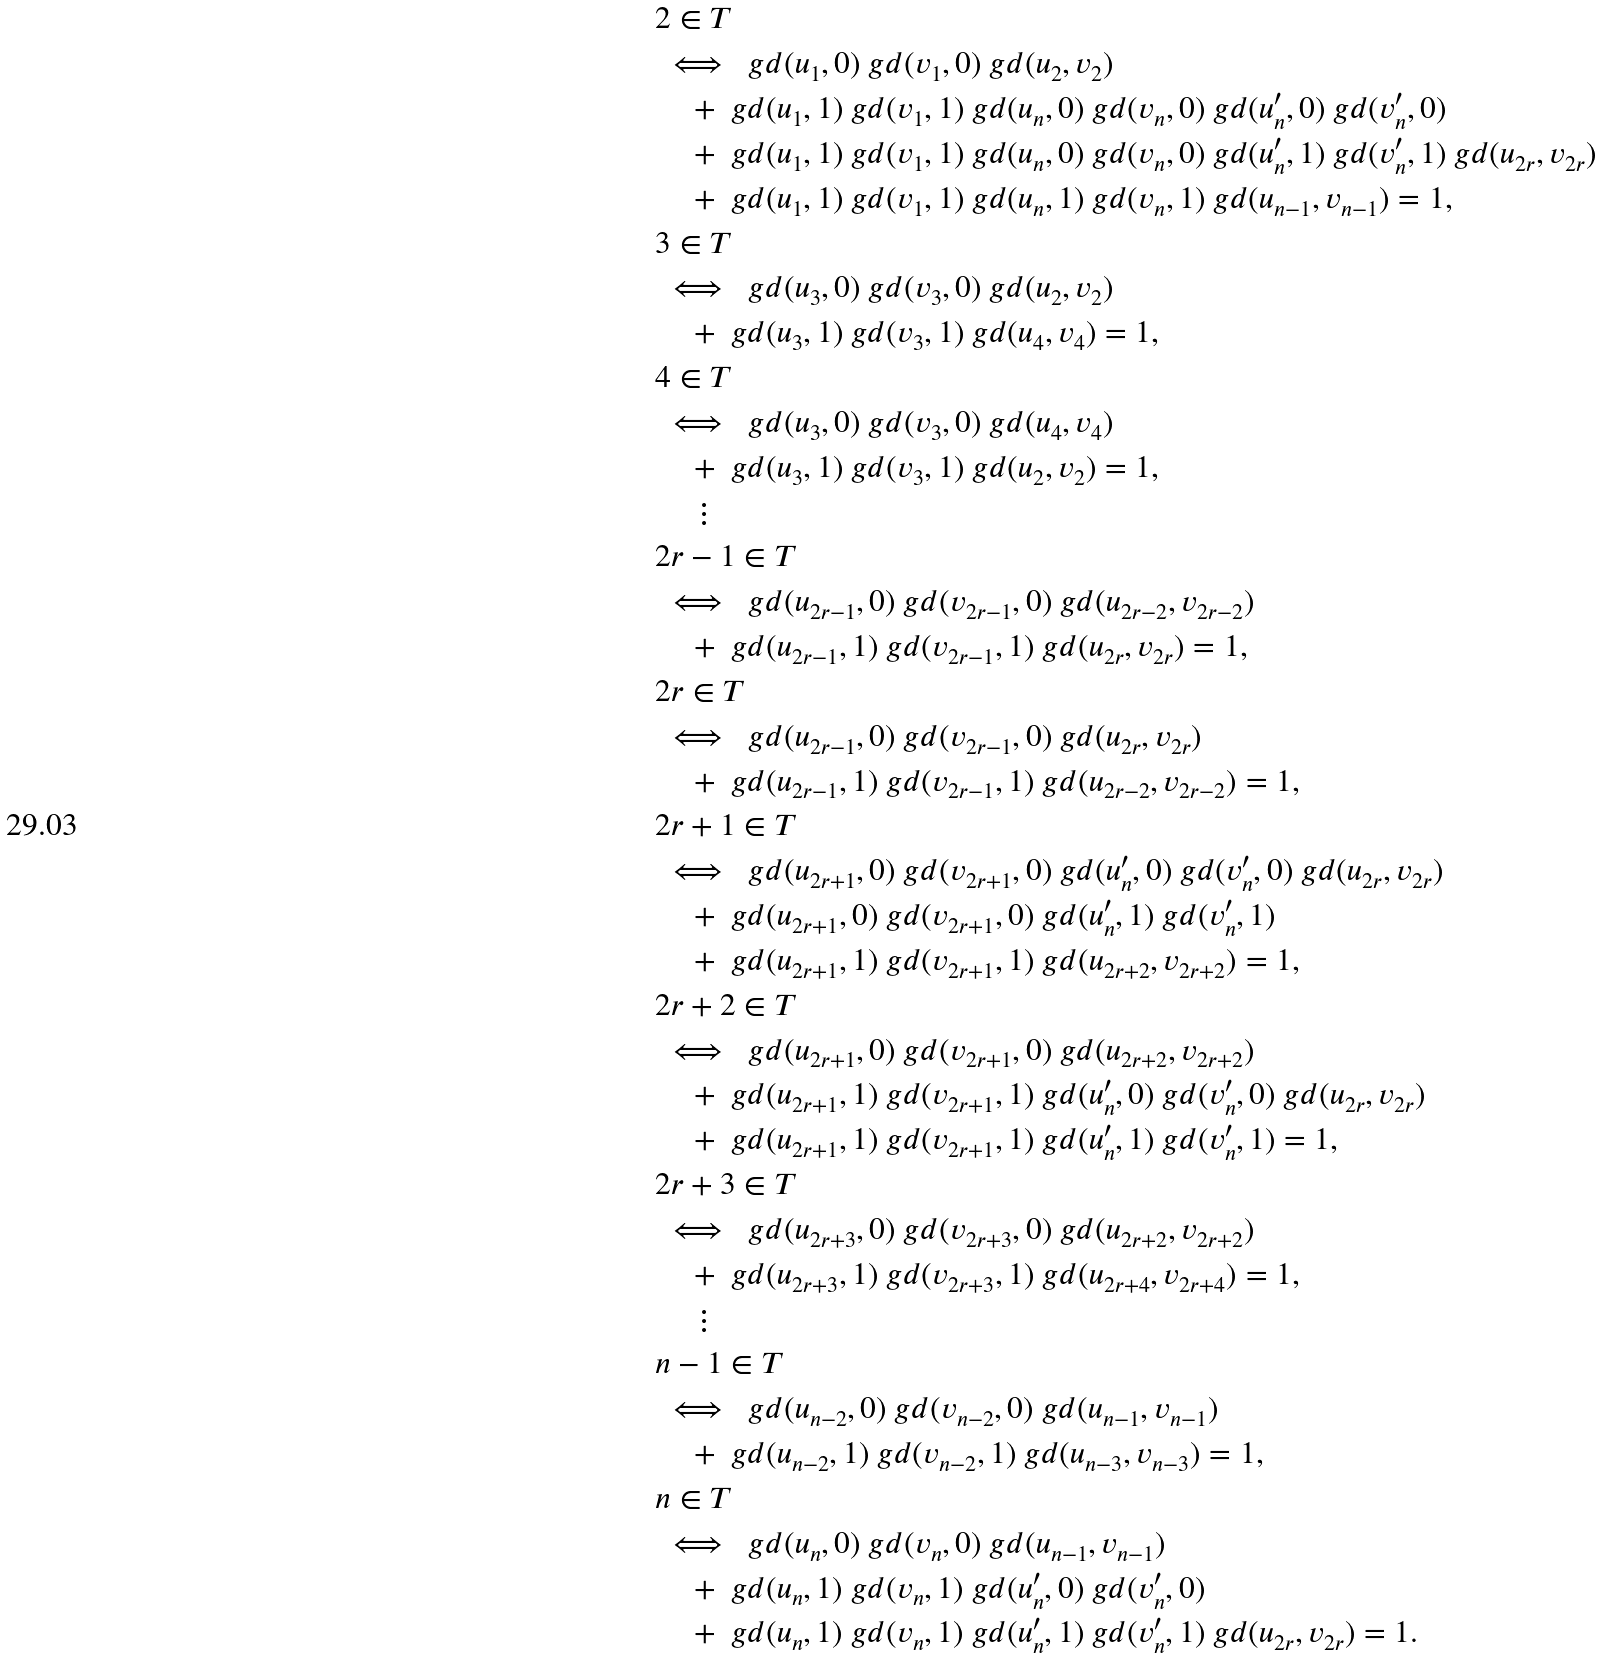Convert formula to latex. <formula><loc_0><loc_0><loc_500><loc_500>& 2 \in T \\ & \iff \ g d ( u _ { 1 } , 0 ) \ g d ( v _ { 1 } , 0 ) \ g d ( u _ { 2 } , v _ { 2 } ) \\ & \quad + \ g d ( u _ { 1 } , 1 ) \ g d ( v _ { 1 } , 1 ) \ g d ( u _ { n } , 0 ) \ g d ( v _ { n } , 0 ) \ g d ( u _ { n } ^ { \prime } , 0 ) \ g d ( v _ { n } ^ { \prime } , 0 ) \\ & \quad + \ g d ( u _ { 1 } , 1 ) \ g d ( v _ { 1 } , 1 ) \ g d ( u _ { n } , 0 ) \ g d ( v _ { n } , 0 ) \ g d ( u _ { n } ^ { \prime } , 1 ) \ g d ( v _ { n } ^ { \prime } , 1 ) \ g d ( u _ { 2 r } , v _ { 2 r } ) \\ & \quad + \ g d ( u _ { 1 } , 1 ) \ g d ( v _ { 1 } , 1 ) \ g d ( u _ { n } , 1 ) \ g d ( v _ { n } , 1 ) \ g d ( u _ { n - 1 } , v _ { n - 1 } ) = 1 , \\ & 3 \in T \\ & \iff \ g d ( u _ { 3 } , 0 ) \ g d ( v _ { 3 } , 0 ) \ g d ( u _ { 2 } , v _ { 2 } ) \\ & \quad + \ g d ( u _ { 3 } , 1 ) \ g d ( v _ { 3 } , 1 ) \ g d ( u _ { 4 } , v _ { 4 } ) = 1 , \\ & 4 \in T \\ & \iff \ g d ( u _ { 3 } , 0 ) \ g d ( v _ { 3 } , 0 ) \ g d ( u _ { 4 } , v _ { 4 } ) \\ & \quad + \ g d ( u _ { 3 } , 1 ) \ g d ( v _ { 3 } , 1 ) \ g d ( u _ { 2 } , v _ { 2 } ) = 1 , \\ & \quad \vdots \\ & 2 r - 1 \in T \\ & \iff \ g d ( u _ { 2 r - 1 } , 0 ) \ g d ( v _ { 2 r - 1 } , 0 ) \ g d ( u _ { 2 r - 2 } , v _ { 2 r - 2 } ) \\ & \quad + \ g d ( u _ { 2 r - 1 } , 1 ) \ g d ( v _ { 2 r - 1 } , 1 ) \ g d ( u _ { 2 r } , v _ { 2 r } ) = 1 , \\ & 2 r \in T \\ & \iff \ g d ( u _ { 2 r - 1 } , 0 ) \ g d ( v _ { 2 r - 1 } , 0 ) \ g d ( u _ { 2 r } , v _ { 2 r } ) \\ & \quad + \ g d ( u _ { 2 r - 1 } , 1 ) \ g d ( v _ { 2 r - 1 } , 1 ) \ g d ( u _ { 2 r - 2 } , v _ { 2 r - 2 } ) = 1 , \\ & 2 r + 1 \in T \\ & \iff \ g d ( u _ { 2 r + 1 } , 0 ) \ g d ( v _ { 2 r + 1 } , 0 ) \ g d ( u _ { n } ^ { \prime } , 0 ) \ g d ( v _ { n } ^ { \prime } , 0 ) \ g d ( u _ { 2 r } , v _ { 2 r } ) \\ & \quad + \ g d ( u _ { 2 r + 1 } , 0 ) \ g d ( v _ { 2 r + 1 } , 0 ) \ g d ( u _ { n } ^ { \prime } , 1 ) \ g d ( v _ { n } ^ { \prime } , 1 ) \\ & \quad + \ g d ( u _ { 2 r + 1 } , 1 ) \ g d ( v _ { 2 r + 1 } , 1 ) \ g d ( u _ { 2 r + 2 } , v _ { 2 r + 2 } ) = 1 , \\ & 2 r + 2 \in T \\ & \iff \ g d ( u _ { 2 r + 1 } , 0 ) \ g d ( v _ { 2 r + 1 } , 0 ) \ g d ( u _ { 2 r + 2 } , v _ { 2 r + 2 } ) \\ & \quad + \ g d ( u _ { 2 r + 1 } , 1 ) \ g d ( v _ { 2 r + 1 } , 1 ) \ g d ( u _ { n } ^ { \prime } , 0 ) \ g d ( v _ { n } ^ { \prime } , 0 ) \ g d ( u _ { 2 r } , v _ { 2 r } ) \\ & \quad + \ g d ( u _ { 2 r + 1 } , 1 ) \ g d ( v _ { 2 r + 1 } , 1 ) \ g d ( u _ { n } ^ { \prime } , 1 ) \ g d ( v _ { n } ^ { \prime } , 1 ) = 1 , \\ & 2 r + 3 \in T \\ & \iff \ g d ( u _ { 2 r + 3 } , 0 ) \ g d ( v _ { 2 r + 3 } , 0 ) \ g d ( u _ { 2 r + 2 } , v _ { 2 r + 2 } ) \\ & \quad + \ g d ( u _ { 2 r + 3 } , 1 ) \ g d ( v _ { 2 r + 3 } , 1 ) \ g d ( u _ { 2 r + 4 } , v _ { 2 r + 4 } ) = 1 , \\ & \quad \vdots \\ & n - 1 \in T \\ & \iff \ g d ( u _ { n - 2 } , 0 ) \ g d ( v _ { n - 2 } , 0 ) \ g d ( u _ { n - 1 } , v _ { n - 1 } ) \\ & \quad + \ g d ( u _ { n - 2 } , 1 ) \ g d ( v _ { n - 2 } , 1 ) \ g d ( u _ { n - 3 } , v _ { n - 3 } ) = 1 , \\ & n \in T \\ & \iff \ g d ( u _ { n } , 0 ) \ g d ( v _ { n } , 0 ) \ g d ( u _ { n - 1 } , v _ { n - 1 } ) \\ & \quad + \ g d ( u _ { n } , 1 ) \ g d ( v _ { n } , 1 ) \ g d ( u _ { n } ^ { \prime } , 0 ) \ g d ( v _ { n } ^ { \prime } , 0 ) \\ & \quad + \ g d ( u _ { n } , 1 ) \ g d ( v _ { n } , 1 ) \ g d ( u _ { n } ^ { \prime } , 1 ) \ g d ( v _ { n } ^ { \prime } , 1 ) \ g d ( u _ { 2 r } , v _ { 2 r } ) = 1 .</formula> 